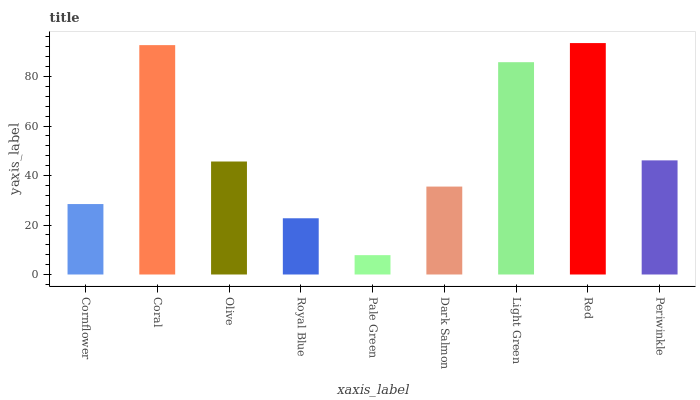Is Pale Green the minimum?
Answer yes or no. Yes. Is Red the maximum?
Answer yes or no. Yes. Is Coral the minimum?
Answer yes or no. No. Is Coral the maximum?
Answer yes or no. No. Is Coral greater than Cornflower?
Answer yes or no. Yes. Is Cornflower less than Coral?
Answer yes or no. Yes. Is Cornflower greater than Coral?
Answer yes or no. No. Is Coral less than Cornflower?
Answer yes or no. No. Is Olive the high median?
Answer yes or no. Yes. Is Olive the low median?
Answer yes or no. Yes. Is Periwinkle the high median?
Answer yes or no. No. Is Light Green the low median?
Answer yes or no. No. 